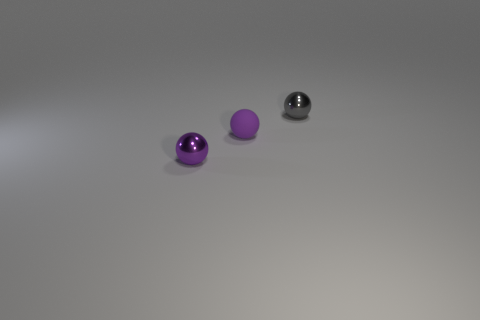Add 2 big yellow matte things. How many objects exist? 5 Subtract all purple rubber cylinders. Subtract all purple shiny objects. How many objects are left? 2 Add 1 tiny gray balls. How many tiny gray balls are left? 2 Add 2 tiny rubber balls. How many tiny rubber balls exist? 3 Subtract 0 purple blocks. How many objects are left? 3 